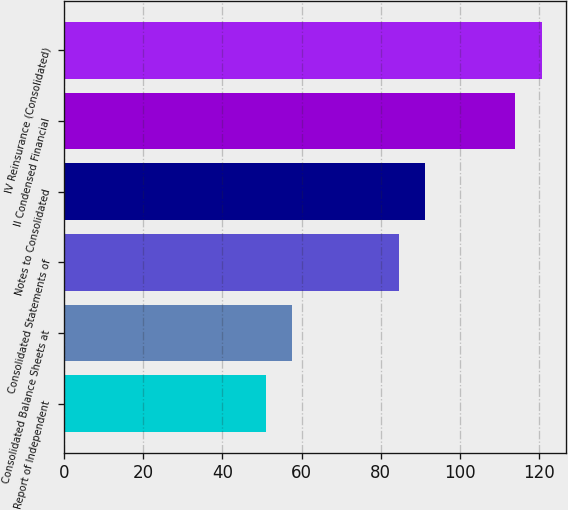Convert chart to OTSL. <chart><loc_0><loc_0><loc_500><loc_500><bar_chart><fcel>Report of Independent<fcel>Consolidated Balance Sheets at<fcel>Consolidated Statements of<fcel>Notes to Consolidated<fcel>II Condensed Financial<fcel>IV Reinsurance (Consolidated)<nl><fcel>51<fcel>57.7<fcel>84.5<fcel>91.2<fcel>114<fcel>120.7<nl></chart> 